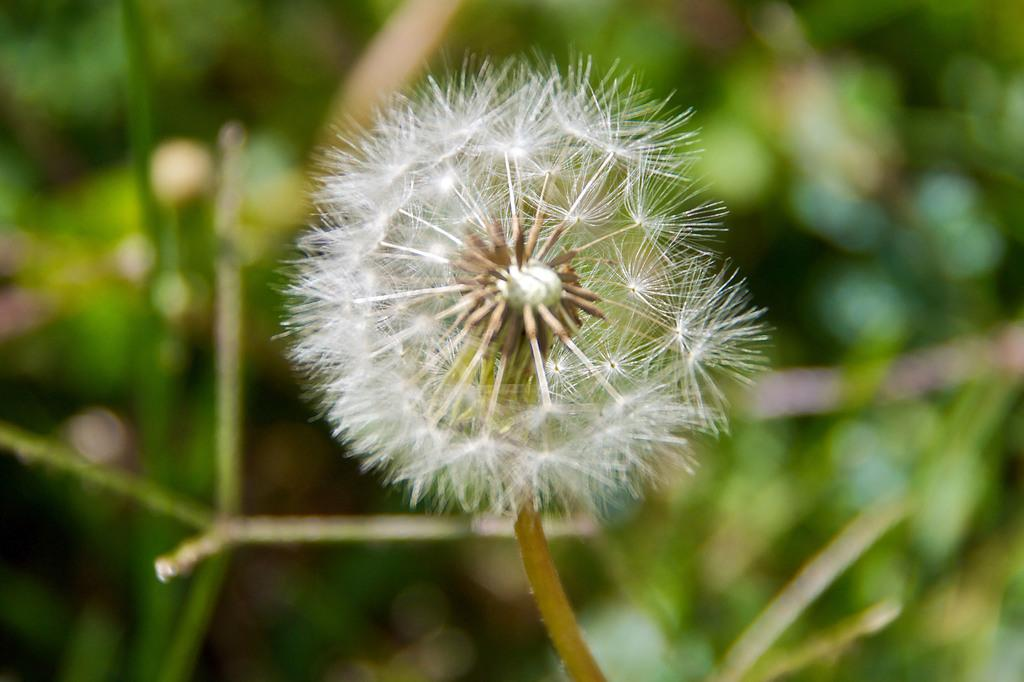What is the main subject of the picture? The main subject of the picture is a dandelion. Can you describe the dandelion in more detail? The dandelion is attached to a stem. What can be seen in the background of the picture? There are plants in the background of the picture. How is the background of the picture depicted? The background is blurred. Can you tell me how many horns are visible on the dandelion in the image? There are no horns present on the dandelion in the image. What type of tooth can be seen growing on the dandelion in the image? There are no teeth present on the dandelion in the image. 